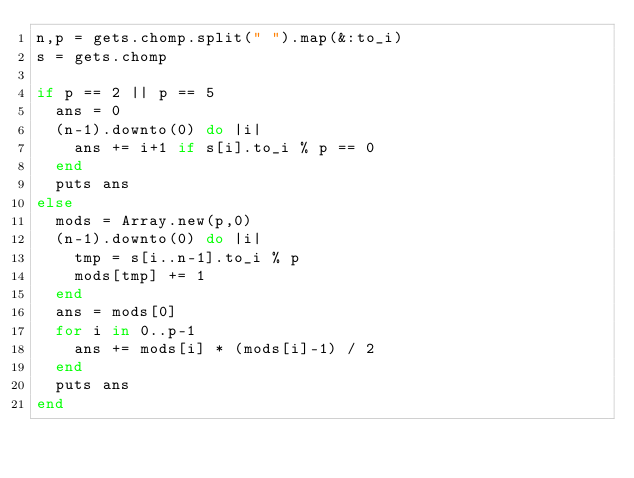<code> <loc_0><loc_0><loc_500><loc_500><_Ruby_>n,p = gets.chomp.split(" ").map(&:to_i)
s = gets.chomp

if p == 2 || p == 5
  ans = 0
  (n-1).downto(0) do |i|
    ans += i+1 if s[i].to_i % p == 0
  end
  puts ans
else
  mods = Array.new(p,0)
  (n-1).downto(0) do |i|
    tmp = s[i..n-1].to_i % p
    mods[tmp] += 1
  end
  ans = mods[0]
  for i in 0..p-1
    ans += mods[i] * (mods[i]-1) / 2
  end
  puts ans
end</code> 